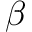<formula> <loc_0><loc_0><loc_500><loc_500>\beta</formula> 